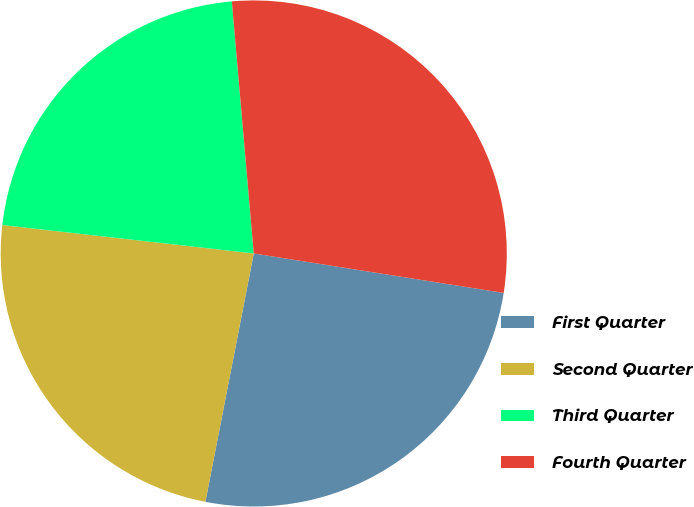Convert chart to OTSL. <chart><loc_0><loc_0><loc_500><loc_500><pie_chart><fcel>First Quarter<fcel>Second Quarter<fcel>Third Quarter<fcel>Fourth Quarter<nl><fcel>25.57%<fcel>23.73%<fcel>21.83%<fcel>28.87%<nl></chart> 